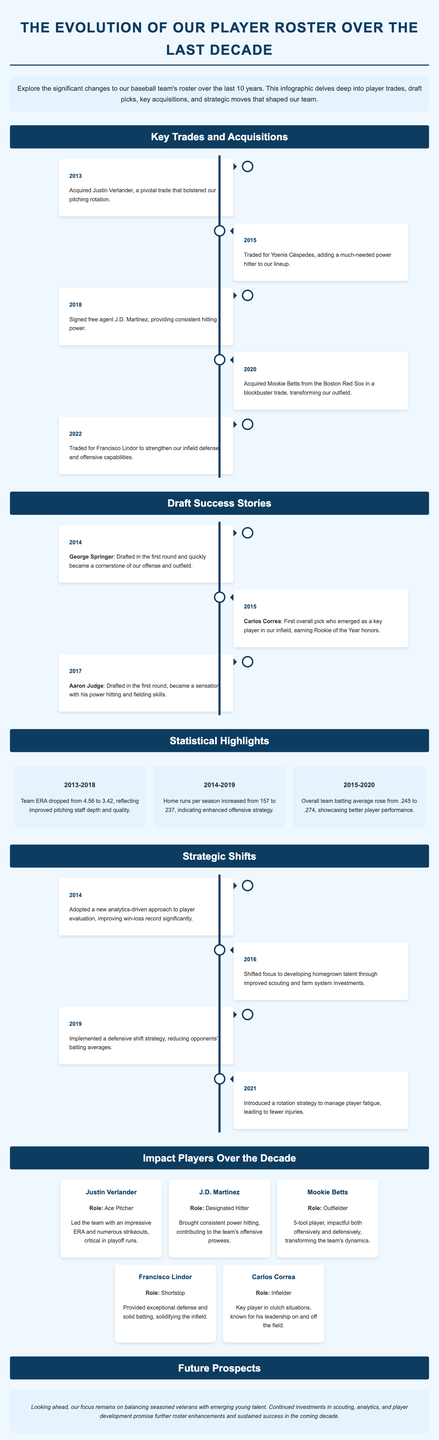What year was Justin Verlander acquired? The document states that Justin Verlander was acquired in 2013.
Answer: 2013 Which player was traded for in 2015? The document mentions that Yoenis Céspedes was traded for in 2015.
Answer: Yoenis Céspedes What significant change happened to the team ERA from 2013 to 2018? The document indicates that the team ERA dropped from 4.56 to 3.42 during this period.
Answer: Dropped to 3.42 Who was the first overall pick in 2015? The document identifies Carlos Correa as the first overall pick in 2015.
Answer: Carlos Correa What strategy was implemented in 2019? The document describes that a defensive shift strategy was implemented in 2019.
Answer: Defensive shift strategy Which player is noted for his leadership on and off the field? The document states that Carlos Correa is recognized for his leadership qualities.
Answer: Carlos Correa What was the role of Mookie Betts? The document specifies that Mookie Betts played as an outfielder.
Answer: Outfielder How many home runs per season increased from 2014 to 2019? The document shows that home runs per season increased from 157 to 237 during this time frame.
Answer: 80 home runs What year did the team adopt an analytics-driven approach? The document mentions that the new analytics-driven approach was adopted in 2014.
Answer: 2014 